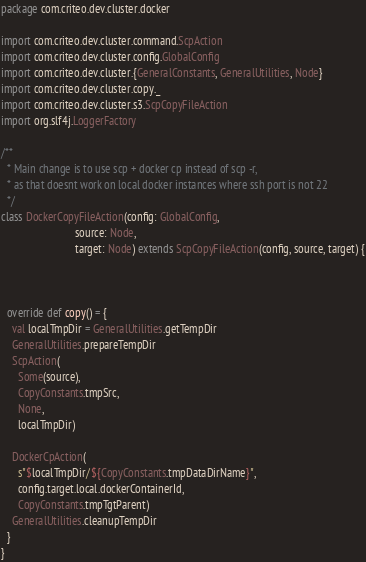<code> <loc_0><loc_0><loc_500><loc_500><_Scala_>package com.criteo.dev.cluster.docker

import com.criteo.dev.cluster.command.ScpAction
import com.criteo.dev.cluster.config.GlobalConfig
import com.criteo.dev.cluster.{GeneralConstants, GeneralUtilities, Node}
import com.criteo.dev.cluster.copy._
import com.criteo.dev.cluster.s3.ScpCopyFileAction
import org.slf4j.LoggerFactory

/**
  * Main change is to use scp + docker cp instead of scp -r,
  * as that doesnt work on local docker instances where ssh port is not 22
  */
class DockerCopyFileAction(config: GlobalConfig,
                           source: Node,
                           target: Node) extends ScpCopyFileAction(config, source, target) {



  override def copy() = {
    val localTmpDir = GeneralUtilities.getTempDir
    GeneralUtilities.prepareTempDir
    ScpAction(
      Some(source),
      CopyConstants.tmpSrc,
      None,
      localTmpDir)

    DockerCpAction(
      s"$localTmpDir/${CopyConstants.tmpDataDirName}",
      config.target.local.dockerContainerId,
      CopyConstants.tmpTgtParent)
    GeneralUtilities.cleanupTempDir
  }
}</code> 